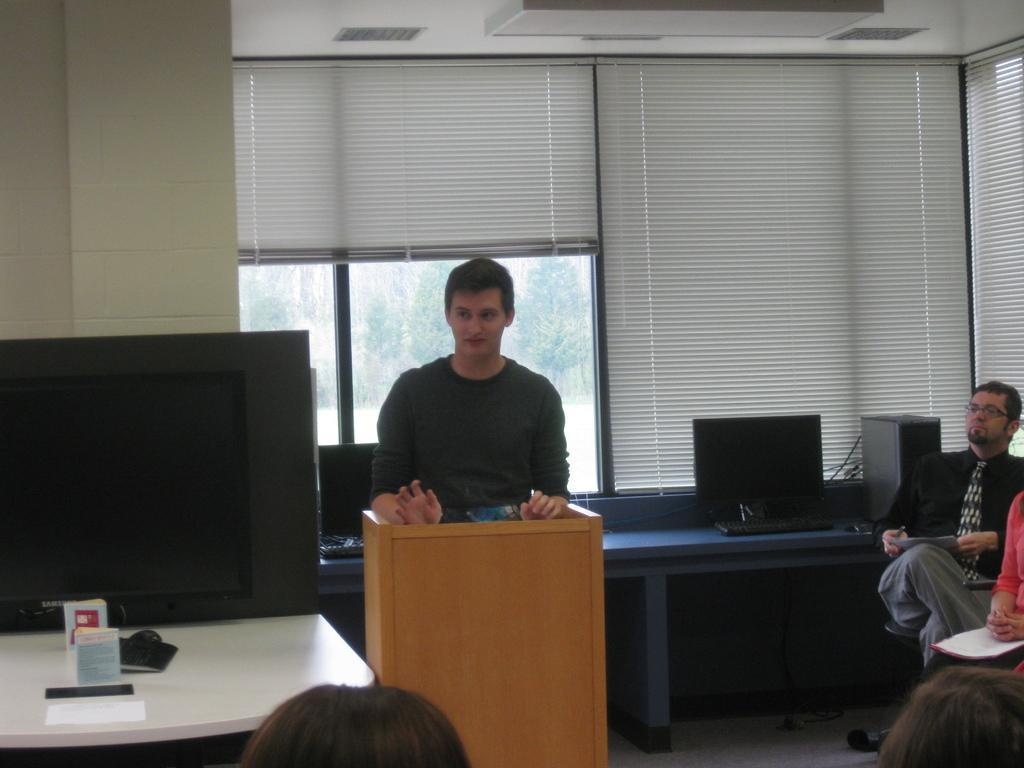In one or two sentences, can you explain what this image depicts? In this image, we can see a few people. We can see some tables with devices on them. We can see the window. We can see the ground and the roof. We can also see some lights. 